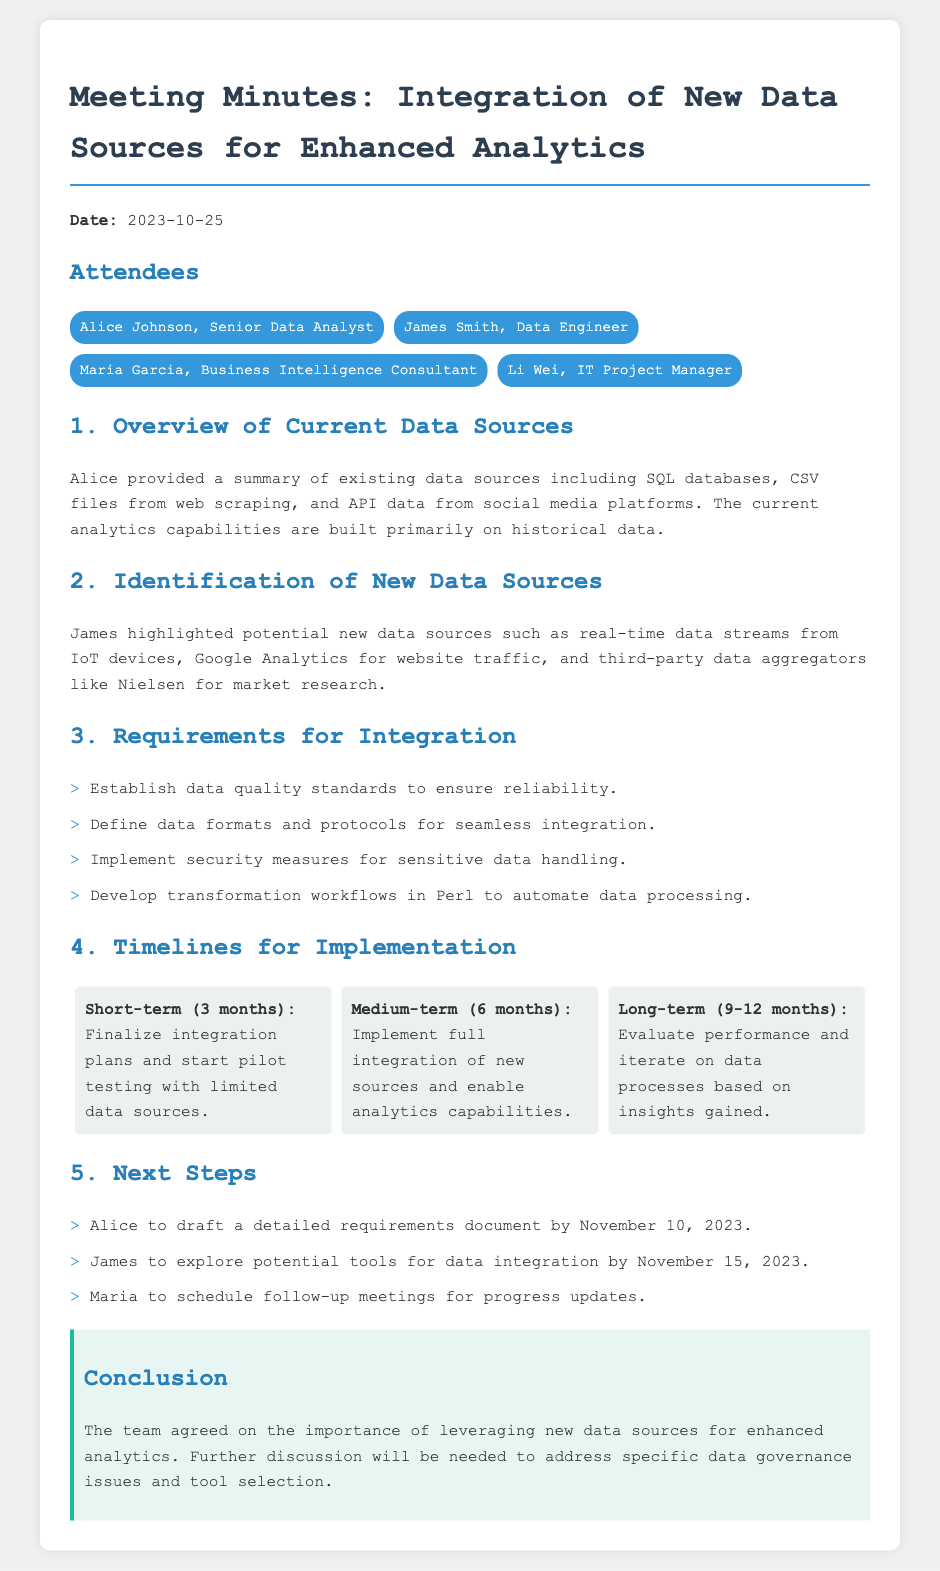What is the date of the meeting? The meeting date is specified at the beginning of the document.
Answer: 2023-10-25 Who summarized the existing data sources? The document states that Alice provided the summary of existing data sources.
Answer: Alice Johnson What are the new data sources identified? James highlighted potential new data sources in the discussion.
Answer: Real-time data streams, Google Analytics, third-party data aggregators What is one requirement for integration mentioned? The document lists specific requirements necessary for integration.
Answer: Establish data quality standards What is the timeline for the short-term implementation? The timeline section outlines specific durations for implementation phases.
Answer: 3 months Who is responsible for drafting the requirements document? The document states that Alice is tasked with drafting the requirements document.
Answer: Alice What is the conclusion regarding the new data sources? The conclusion section summarizes the team's agreement on the subject.
Answer: Importance of leveraging new data sources for enhanced analytics How many attendees were present at the meeting? The attendees section lists the participants present during the meeting.
Answer: Four 